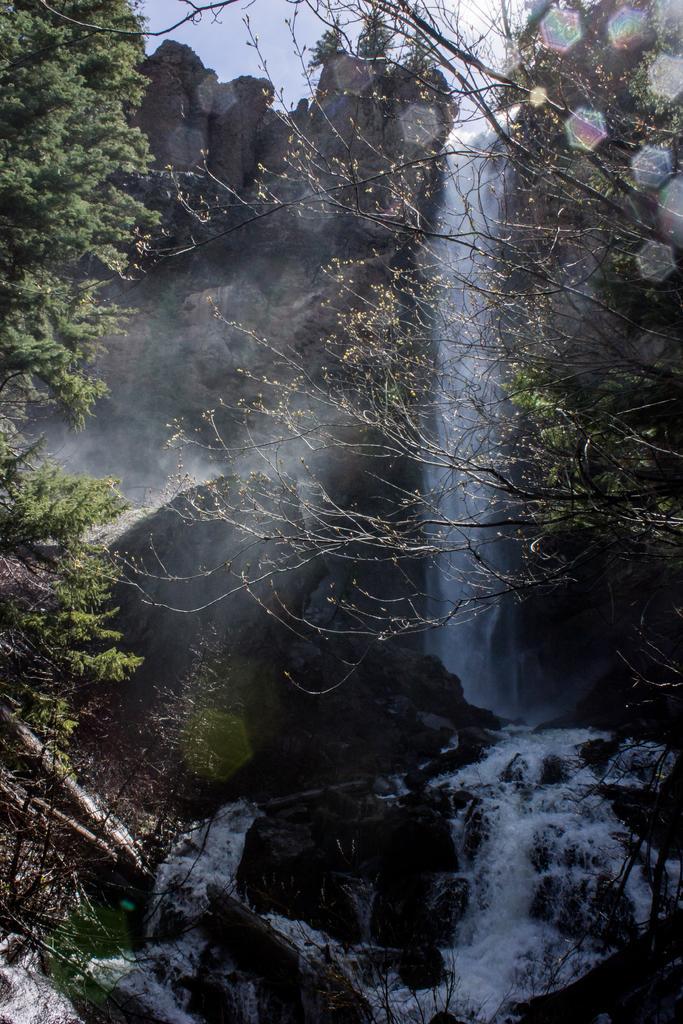In one or two sentences, can you explain what this image depicts? On the left side, there are trees on hill. On the right side, there are trees on hill. In the background, there is a waterfall from the mountain and there is sky. 